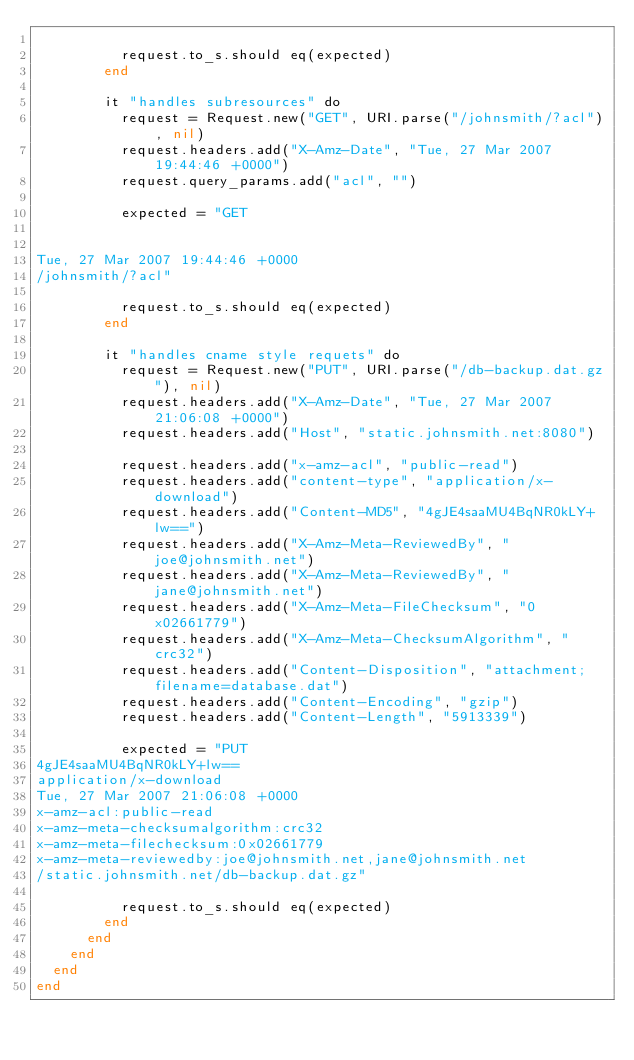Convert code to text. <code><loc_0><loc_0><loc_500><loc_500><_Crystal_>
          request.to_s.should eq(expected)
        end

        it "handles subresources" do
          request = Request.new("GET", URI.parse("/johnsmith/?acl"), nil)
          request.headers.add("X-Amz-Date", "Tue, 27 Mar 2007 19:44:46 +0000")
          request.query_params.add("acl", "")

          expected = "GET


Tue, 27 Mar 2007 19:44:46 +0000
/johnsmith/?acl"

          request.to_s.should eq(expected)
        end

        it "handles cname style requets" do
          request = Request.new("PUT", URI.parse("/db-backup.dat.gz"), nil)
          request.headers.add("X-Amz-Date", "Tue, 27 Mar 2007 21:06:08 +0000")
          request.headers.add("Host", "static.johnsmith.net:8080")

          request.headers.add("x-amz-acl", "public-read")
          request.headers.add("content-type", "application/x-download")
          request.headers.add("Content-MD5", "4gJE4saaMU4BqNR0kLY+lw==")
          request.headers.add("X-Amz-Meta-ReviewedBy", "joe@johnsmith.net")
          request.headers.add("X-Amz-Meta-ReviewedBy", "jane@johnsmith.net")
          request.headers.add("X-Amz-Meta-FileChecksum", "0x02661779")
          request.headers.add("X-Amz-Meta-ChecksumAlgorithm", "crc32")
          request.headers.add("Content-Disposition", "attachment; filename=database.dat")
          request.headers.add("Content-Encoding", "gzip")
          request.headers.add("Content-Length", "5913339")

          expected = "PUT
4gJE4saaMU4BqNR0kLY+lw==
application/x-download
Tue, 27 Mar 2007 21:06:08 +0000
x-amz-acl:public-read
x-amz-meta-checksumalgorithm:crc32
x-amz-meta-filechecksum:0x02661779
x-amz-meta-reviewedby:joe@johnsmith.net,jane@johnsmith.net
/static.johnsmith.net/db-backup.dat.gz"

          request.to_s.should eq(expected)
        end
      end
    end
  end
end
</code> 